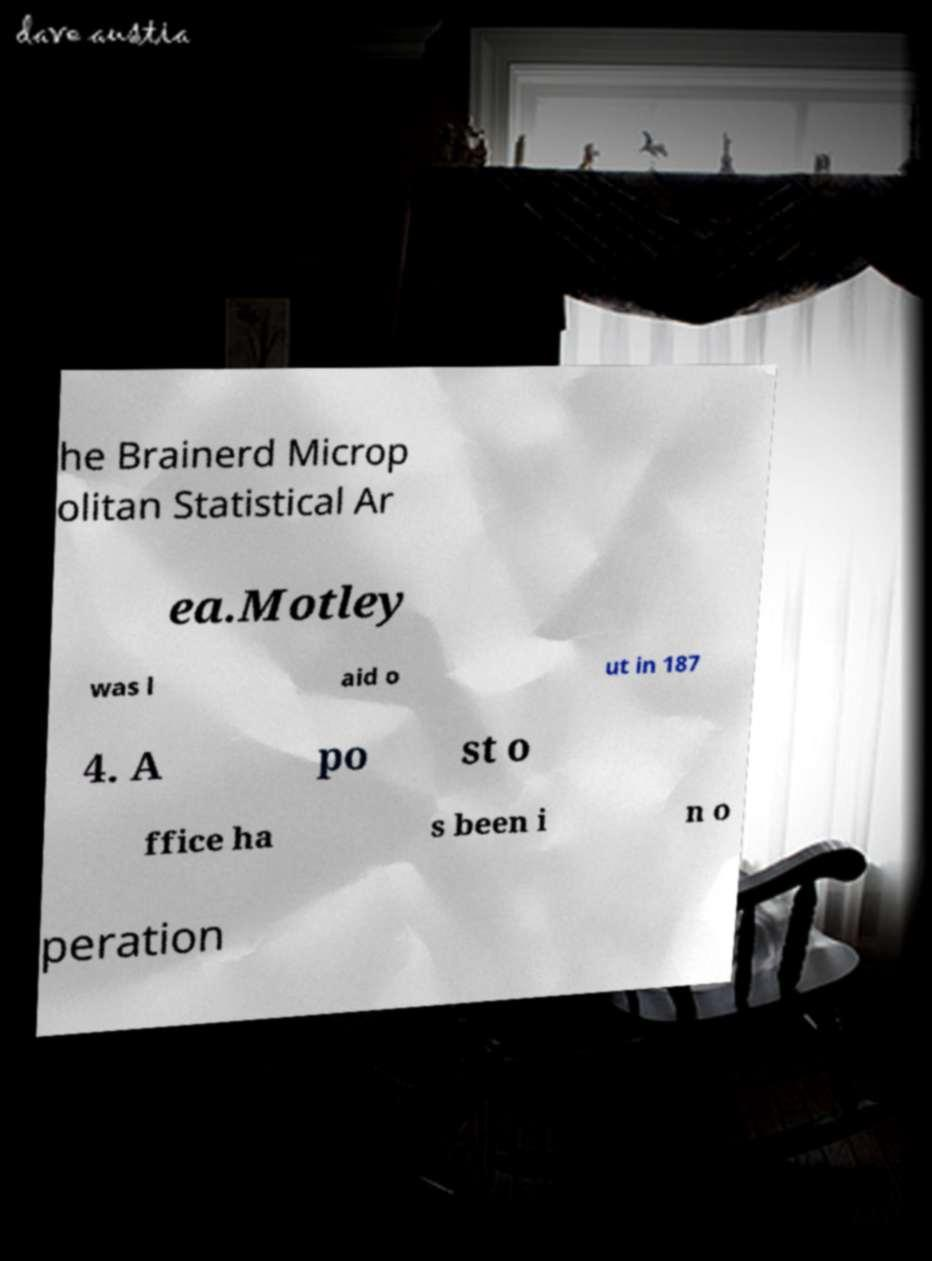What messages or text are displayed in this image? I need them in a readable, typed format. he Brainerd Microp olitan Statistical Ar ea.Motley was l aid o ut in 187 4. A po st o ffice ha s been i n o peration 